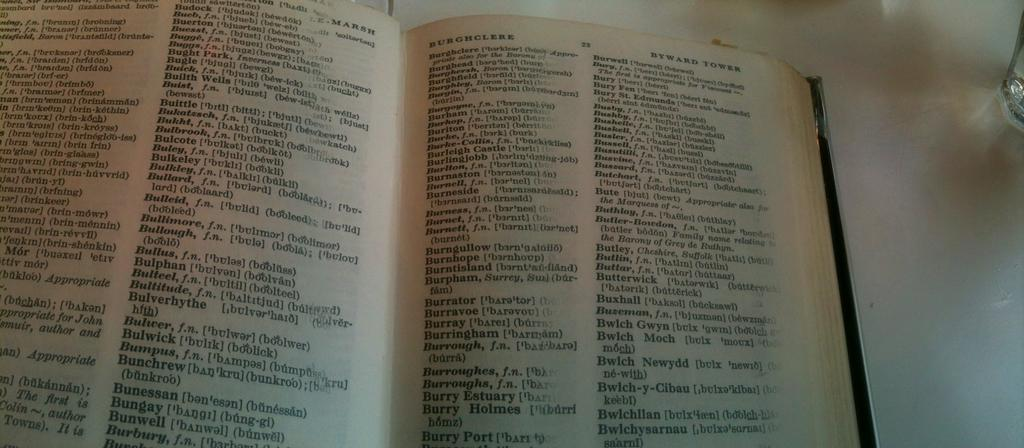What is the main object in the image? There is an open book in the image. Where is the open book located? The open book is placed on a table. Can you describe any other objects visible in the image? There is a glass tumbler in the background of the image. What type of quill is being used to write in the open book? There is no quill visible in the image, and the open book does not show any writing. 